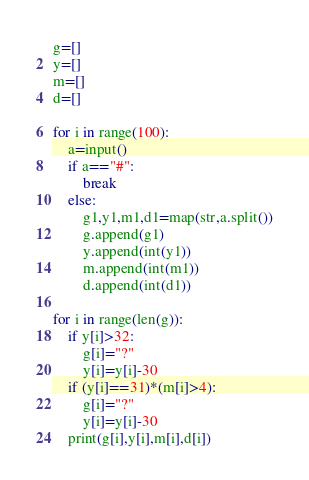Convert code to text. <code><loc_0><loc_0><loc_500><loc_500><_Python_>g=[]
y=[]
m=[]
d=[]

for i in range(100):
    a=input()
    if a=="#":
        break
    else:
        g1,y1,m1,d1=map(str,a.split())
        g.append(g1)
        y.append(int(y1))
        m.append(int(m1))
        d.append(int(d1))

for i in range(len(g)):
    if y[i]>32:
        g[i]="?"
        y[i]=y[i]-30
    if (y[i]==31)*(m[i]>4):
        g[i]="?"
        y[i]=y[i]-30
    print(g[i],y[i],m[i],d[i])

</code> 